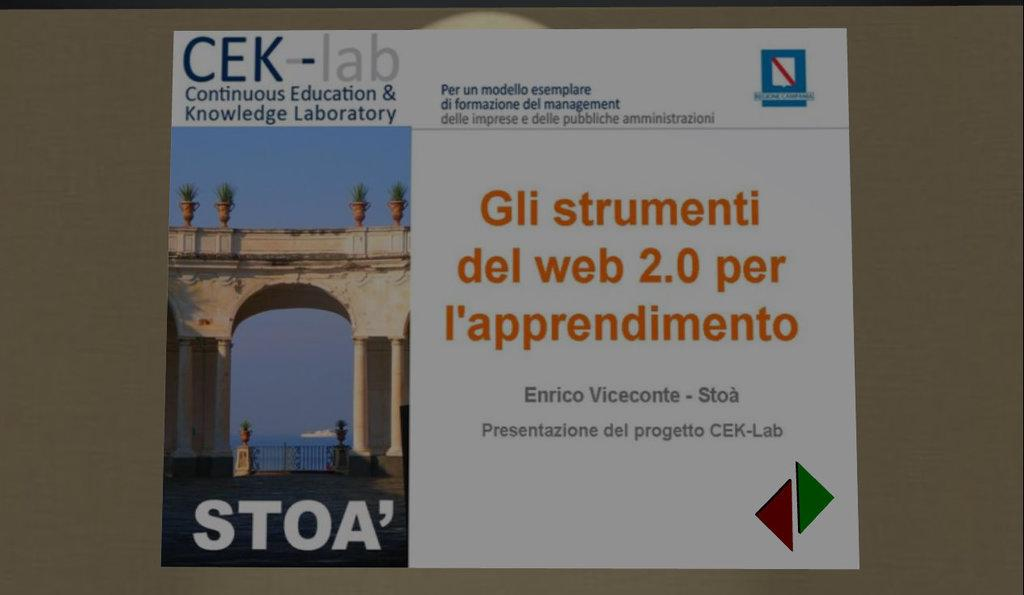<image>
Render a clear and concise summary of the photo. An information packet for STOA sits displaying the front. 